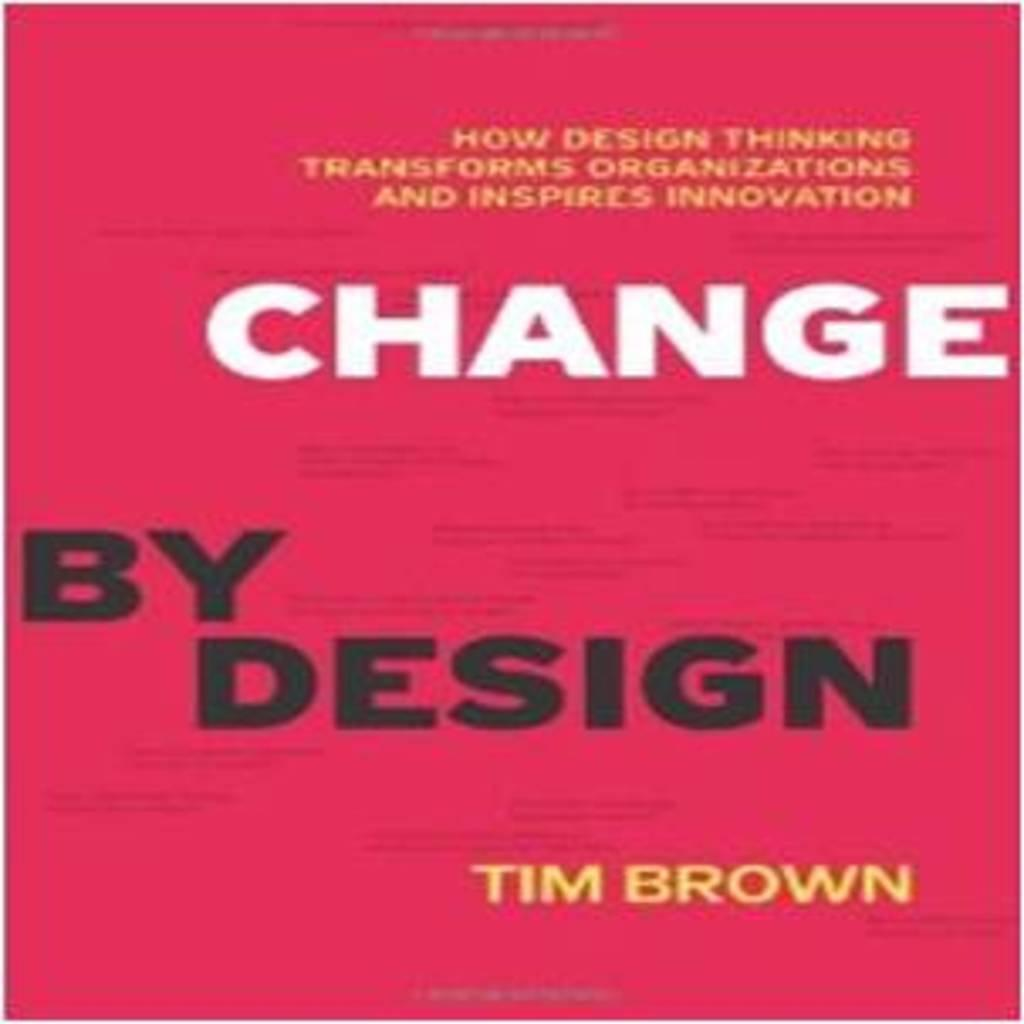<image>
Create a compact narrative representing the image presented. Label that says Change by Design by Tim Brown. 